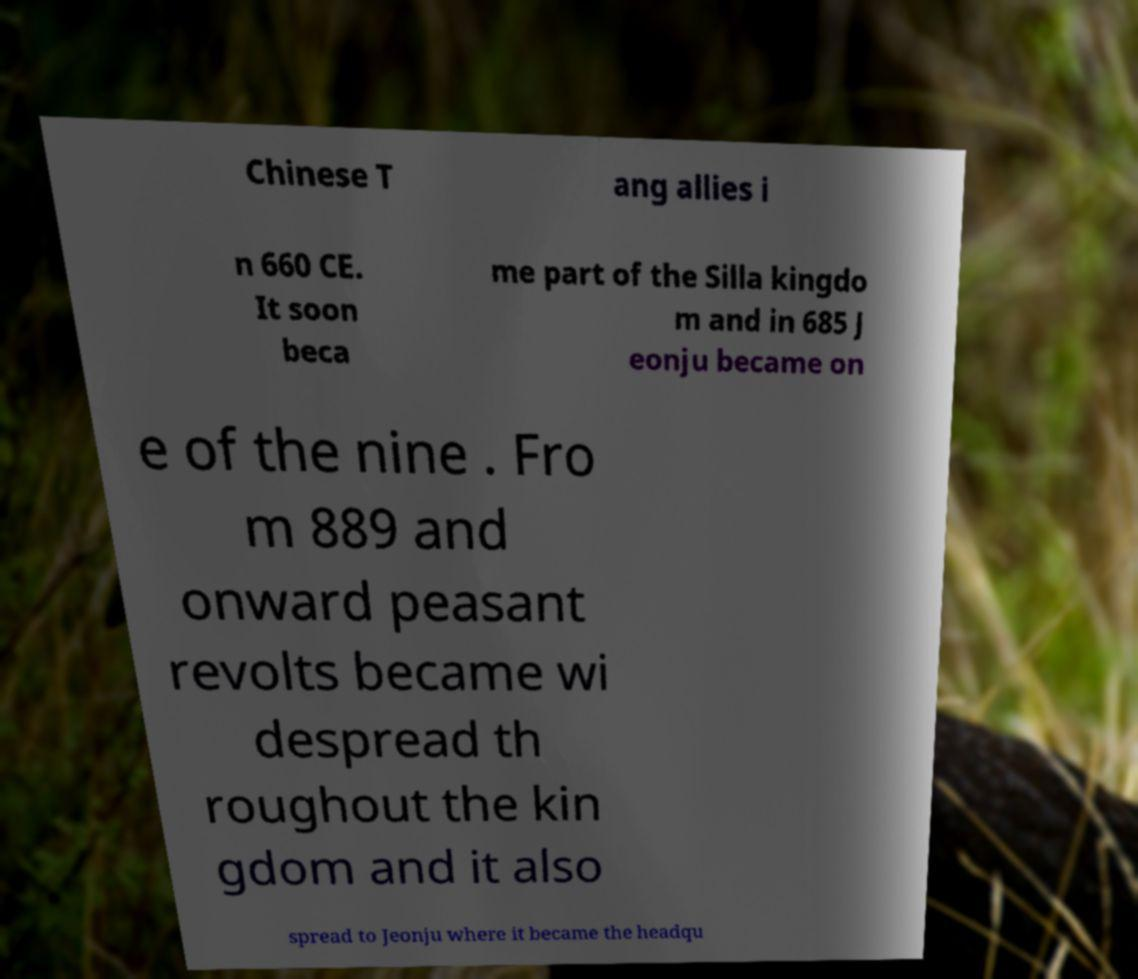I need the written content from this picture converted into text. Can you do that? Chinese T ang allies i n 660 CE. It soon beca me part of the Silla kingdo m and in 685 J eonju became on e of the nine . Fro m 889 and onward peasant revolts became wi despread th roughout the kin gdom and it also spread to Jeonju where it became the headqu 